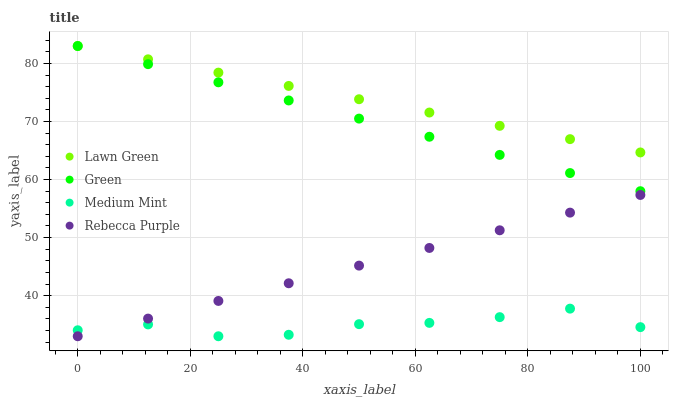Does Medium Mint have the minimum area under the curve?
Answer yes or no. Yes. Does Lawn Green have the maximum area under the curve?
Answer yes or no. Yes. Does Green have the minimum area under the curve?
Answer yes or no. No. Does Green have the maximum area under the curve?
Answer yes or no. No. Is Rebecca Purple the smoothest?
Answer yes or no. Yes. Is Medium Mint the roughest?
Answer yes or no. Yes. Is Lawn Green the smoothest?
Answer yes or no. No. Is Lawn Green the roughest?
Answer yes or no. No. Does Medium Mint have the lowest value?
Answer yes or no. Yes. Does Green have the lowest value?
Answer yes or no. No. Does Green have the highest value?
Answer yes or no. Yes. Does Rebecca Purple have the highest value?
Answer yes or no. No. Is Rebecca Purple less than Green?
Answer yes or no. Yes. Is Lawn Green greater than Medium Mint?
Answer yes or no. Yes. Does Rebecca Purple intersect Medium Mint?
Answer yes or no. Yes. Is Rebecca Purple less than Medium Mint?
Answer yes or no. No. Is Rebecca Purple greater than Medium Mint?
Answer yes or no. No. Does Rebecca Purple intersect Green?
Answer yes or no. No. 